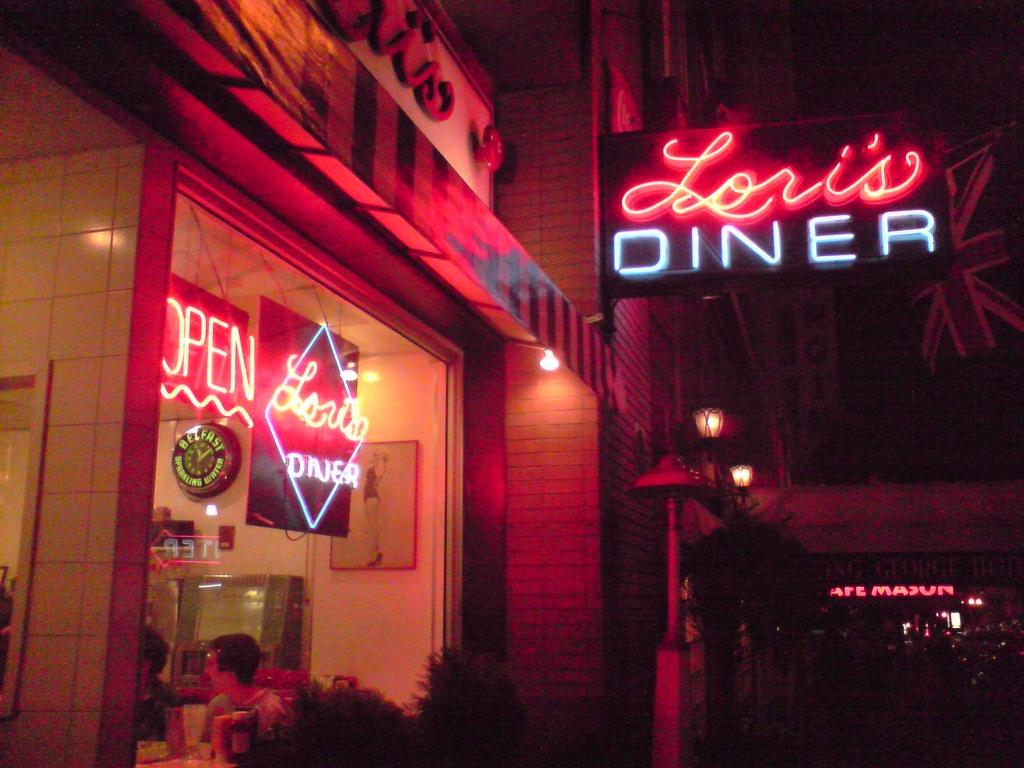<image>
Present a compact description of the photo's key features. A neon sign lit up that says Lori's Diner on it in blue and red colors 